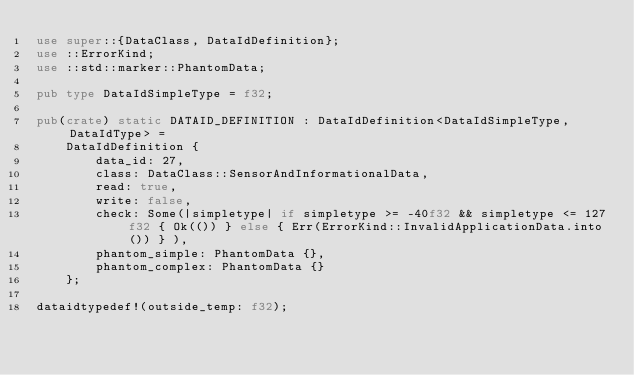<code> <loc_0><loc_0><loc_500><loc_500><_Rust_>use super::{DataClass, DataIdDefinition};
use ::ErrorKind;
use ::std::marker::PhantomData;

pub type DataIdSimpleType = f32;

pub(crate) static DATAID_DEFINITION : DataIdDefinition<DataIdSimpleType, DataIdType> =
    DataIdDefinition {
        data_id: 27,
        class: DataClass::SensorAndInformationalData,
        read: true,
        write: false,
        check: Some(|simpletype| if simpletype >= -40f32 && simpletype <= 127f32 { Ok(()) } else { Err(ErrorKind::InvalidApplicationData.into()) } ),
        phantom_simple: PhantomData {},
        phantom_complex: PhantomData {}
    };

dataidtypedef!(outside_temp: f32);</code> 